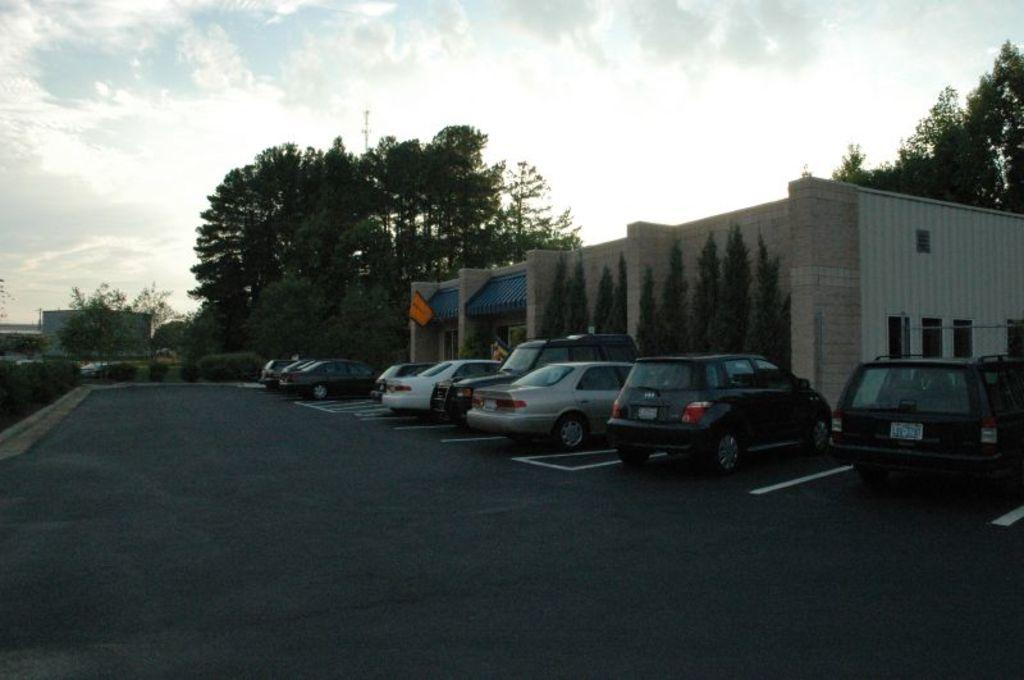What type of vehicles can be seen on the road in the image? There are cars on the road in the image. What other objects or features can be seen in the image? There are trees and a building in the image. How would you describe the weather in the image? The sky is cloudy in the image. How many rings are visible on the building in the image? There are no rings visible on the building in the image. What type of cakes are being served at the event in the image? There is no event or cakes present in the image. 